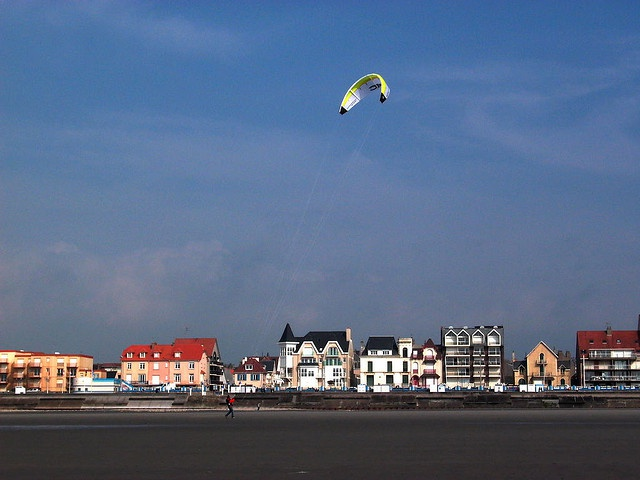Describe the objects in this image and their specific colors. I can see kite in gray, white, olive, and black tones, people in gray, black, maroon, and brown tones, car in gray, darkgray, black, and maroon tones, car in gray, black, navy, and darkblue tones, and skis in gray and black tones in this image. 